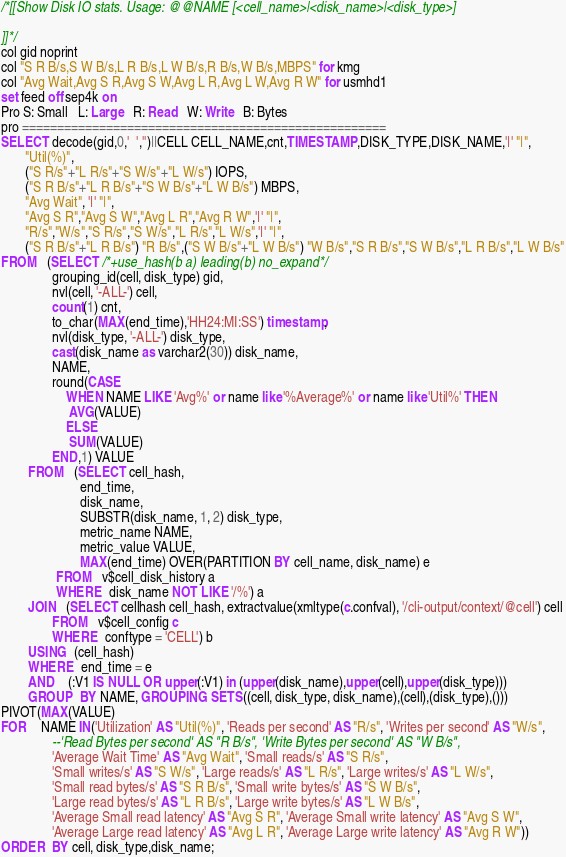<code> <loc_0><loc_0><loc_500><loc_500><_SQL_>/*[[Show Disk IO stats. Usage: @@NAME [<cell_name>|<disk_name>|<disk_type>]

]]*/
col gid noprint
col "S R B/s,S W B/s,L R B/s,L W B/s,R B/s,W B/s,MBPS" for kmg
col "Avg Wait,Avg S R,Avg S W,Avg L R,Avg L W,Avg R W" for usmhd1
set feed off sep4k on
Pro S: Small   L: Large   R: Read   W: Write   B: Bytes
pro ====================================================
SELECT decode(gid,0,'  ','')||CELL CELL_NAME,cnt,TIMESTAMP,DISK_TYPE,DISK_NAME,'|' "|",
       "Util(%)",
       ("S R/s"+"L R/s"+"S W/s"+"L W/s") IOPS,
       ("S R B/s"+"L R B/s"+"S W B/s"+"L W B/s") MBPS,
       "Avg Wait", '|' "|",
       "Avg S R","Avg S W","Avg L R","Avg R W",'|' "|",
       "R/s","W/s","S R/s","S W/s","L R/s","L W/s",'|' "|",
       ("S R B/s"+"L R B/s") "R B/s",("S W B/s"+"L W B/s") "W B/s","S R B/s","S W B/s","L R B/s","L W B/s"
FROM   (SELECT /*+use_hash(b a) leading(b) no_expand*/ 
               grouping_id(cell, disk_type) gid,
               nvl(cell, '-ALL-') cell,
               count(1) cnt,
               to_char(MAX(end_time),'HH24:MI:SS') timestamp,
               nvl(disk_type, '-ALL-') disk_type,
               cast(disk_name as varchar2(30)) disk_name,
               NAME,
               round(CASE
                   WHEN NAME LIKE 'Avg%' or name like '%Average%' or name like 'Util%' THEN
                    AVG(VALUE)
                   ELSE
                    SUM(VALUE)
               END,1) VALUE
        FROM   (SELECT cell_hash,
                       end_time,
                       disk_name,
                       SUBSTR(disk_name, 1, 2) disk_type,
                       metric_name NAME,
                       metric_value VALUE,
                       MAX(end_time) OVER(PARTITION BY cell_name, disk_name) e
                FROM   v$cell_disk_history a
                WHERE  disk_name NOT LIKE '/%') a 
        JOIN   (SELECT cellhash cell_hash, extractvalue(xmltype(c.confval), '/cli-output/context/@cell') cell
               FROM   v$cell_config c
               WHERE  conftype = 'CELL') b
        USING  (cell_hash)
        WHERE  end_time = e
        AND    (:V1 IS NULL OR upper(:V1) in (upper(disk_name),upper(cell),upper(disk_type)))
        GROUP  BY NAME, GROUPING SETS((cell, disk_type, disk_name),(cell),(disk_type),()))
PIVOT(MAX(VALUE)
FOR    NAME IN('Utilization' AS "Util(%)", 'Reads per second' AS "R/s", 'Writes per second' AS "W/s",
               --'Read Bytes per second' AS "R B/s", 'Write Bytes per second' AS "W B/s",
               'Average Wait Time' AS "Avg Wait", 'Small reads/s' AS "S R/s",
               'Small writes/s' AS "S W/s", 'Large reads/s' AS "L R/s", 'Large writes/s' AS "L W/s",
               'Small read bytes/s' AS "S R B/s", 'Small write bytes/s' AS "S W B/s",
               'Large read bytes/s' AS "L R B/s", 'Large write bytes/s' AS "L W B/s",
               'Average Small read latency' AS "Avg S R", 'Average Small write latency' AS "Avg S W",
               'Average Large read latency' AS "Avg L R", 'Average Large write latency' AS "Avg R W"))
ORDER  BY cell, disk_type,disk_name;
</code> 